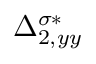<formula> <loc_0><loc_0><loc_500><loc_500>\Delta _ { 2 , y y } ^ { \sigma * }</formula> 